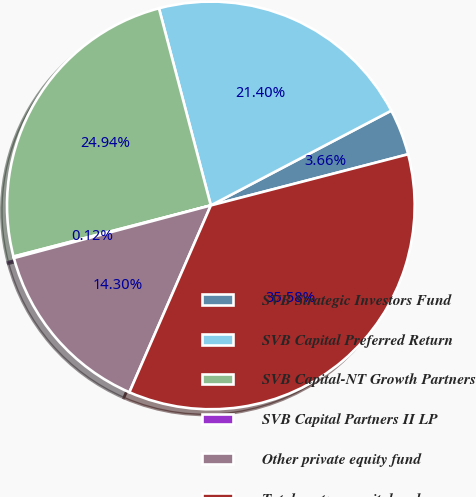<chart> <loc_0><loc_0><loc_500><loc_500><pie_chart><fcel>SVB Strategic Investors Fund<fcel>SVB Capital Preferred Return<fcel>SVB Capital-NT Growth Partners<fcel>SVB Capital Partners II LP<fcel>Other private equity fund<fcel>Total venture capital and<nl><fcel>3.66%<fcel>21.4%<fcel>24.94%<fcel>0.12%<fcel>14.3%<fcel>35.58%<nl></chart> 